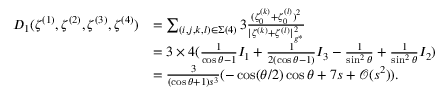<formula> <loc_0><loc_0><loc_500><loc_500>\begin{array} { r l } { D _ { 1 } ( \zeta ^ { ( 1 ) } , \zeta ^ { ( 2 ) } , \zeta ^ { ( 3 ) } , \zeta ^ { ( 4 ) } ) } & { = \sum _ { ( i , j , k , l ) \in \Sigma ( 4 ) } 3 \frac { ( \zeta _ { 0 } ^ { ( k ) } + \zeta _ { 0 } ^ { ( l ) } ) ^ { 2 } } { | { \zeta ^ { ( k ) } } + { \zeta ^ { ( l ) } } | _ { g ^ { * } } ^ { 2 } } } \\ & { = 3 \times 4 ( \frac { 1 } { \cos \theta - 1 } I _ { 1 } + \frac { 1 } { 2 ( \cos \theta - 1 ) } I _ { 3 } - \frac { 1 } { \sin ^ { 2 } \theta } + \frac { 1 } { \sin ^ { 2 } \theta } I _ { 2 } ) } \\ & { = \frac { 3 } { ( \cos \theta + 1 ) s ^ { 3 } } ( - \cos ( { \theta } / { 2 } ) \cos \theta + 7 s + \mathcal { O } ( s ^ { 2 } ) ) . } \end{array}</formula> 